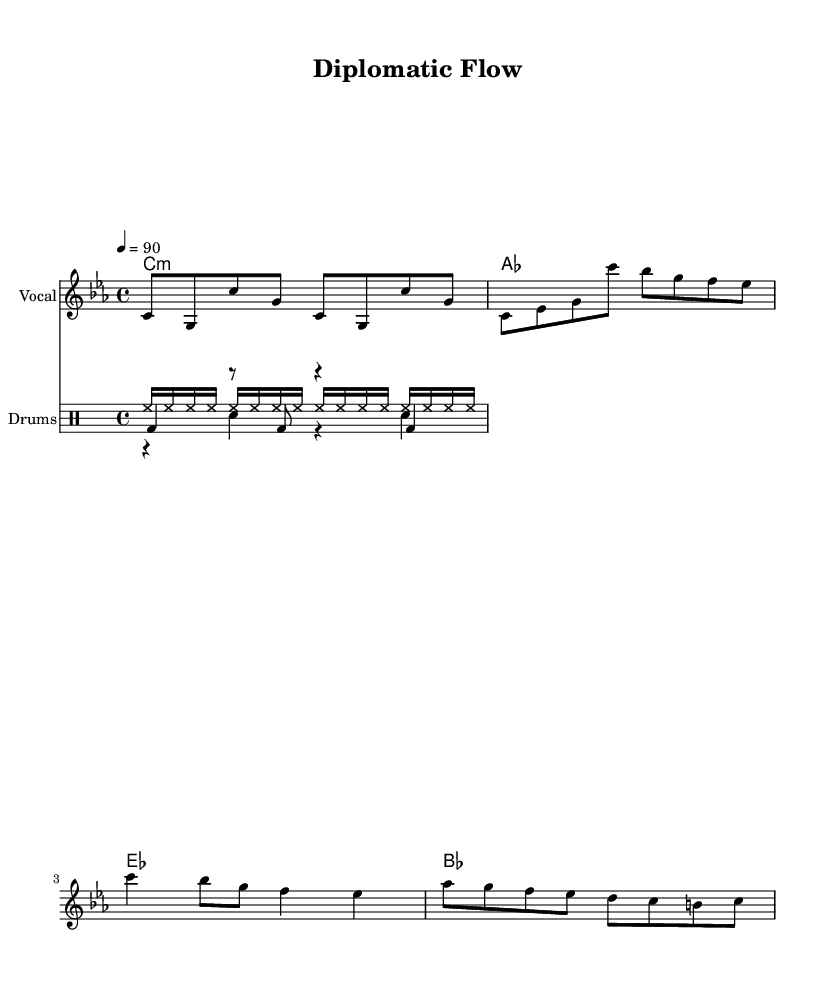What is the key signature of this music? The key signature indicated in the sheet music is C minor, which typically features three flats (B♭, E♭, and A♭). This is identified by examining the key signature section at the start of the staff where the arrangement is presented.
Answer: C minor What is the time signature of this music? The time signature shown is 4/4, meaning each measure has four beats, and each beat is a quarter note. This can be confirmed by looking at the notation at the beginning of the piece where the time is specified.
Answer: 4/4 What is the tempo of this music? The tempo marking indicates 90 beats per minute, which means the piece should be played at a moderate pace. The tempo is noted with the instruction placed above the staff, typically near the start of the sheet music.
Answer: 90 What type of music does this sheet represent? The music type represented in this sheet is Rap, primarily distinguished by its rhythmic vocal delivery and beat structure that includes a strong emphasis on beats and rhythm. The style can be inferred from the title and context of the lyrics as well as the general composition format.
Answer: Rap How many measures are in the verse section? The verse section, as shown in the melody notation, contains four measures. By closely counting the bars, you can see that four groupings represent the rhythmic phrasing typical of the verse in Rap.
Answer: 4 What instruments are included in this score? The score includes a vocal instrument, indicating the main rap performance, along with a drum set consisting of hi-hat, snare, and kick drum. This can be ascertained from the designated staves at the beginning of the score which label the instruments present.
Answer: Vocal and Drums 